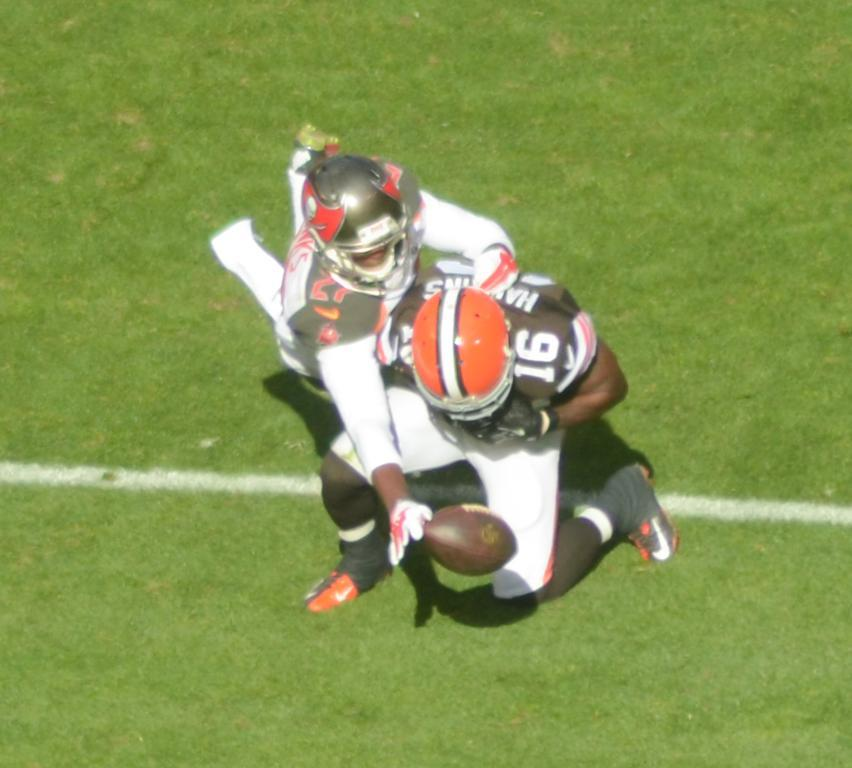How many people are in the image? There are two people in the image. What are the people doing in the image? The people are standing on the ground. What object is in the air in the image? There is a rugby ball in the air. What protective gear are the people wearing? The people are wearing helmets. What type of surface is the ground covered with? The ground is covered with grass. Where is the stove located in the image? There is no stove present in the image. What type of patch can be seen on the people's clothing in the image? There is no patch visible on the people's clothing in the image. 